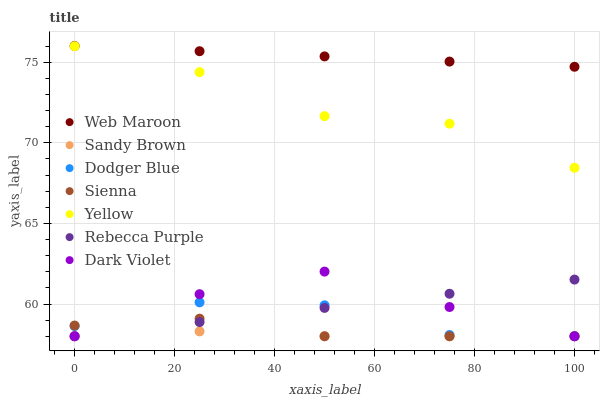Does Sandy Brown have the minimum area under the curve?
Answer yes or no. Yes. Does Web Maroon have the maximum area under the curve?
Answer yes or no. Yes. Does Yellow have the minimum area under the curve?
Answer yes or no. No. Does Yellow have the maximum area under the curve?
Answer yes or no. No. Is Rebecca Purple the smoothest?
Answer yes or no. Yes. Is Yellow the roughest?
Answer yes or no. Yes. Is Web Maroon the smoothest?
Answer yes or no. No. Is Web Maroon the roughest?
Answer yes or no. No. Does Dark Violet have the lowest value?
Answer yes or no. Yes. Does Yellow have the lowest value?
Answer yes or no. No. Does Web Maroon have the highest value?
Answer yes or no. Yes. Does Yellow have the highest value?
Answer yes or no. No. Is Sandy Brown less than Web Maroon?
Answer yes or no. Yes. Is Web Maroon greater than Sandy Brown?
Answer yes or no. Yes. Does Sandy Brown intersect Sienna?
Answer yes or no. Yes. Is Sandy Brown less than Sienna?
Answer yes or no. No. Is Sandy Brown greater than Sienna?
Answer yes or no. No. Does Sandy Brown intersect Web Maroon?
Answer yes or no. No. 